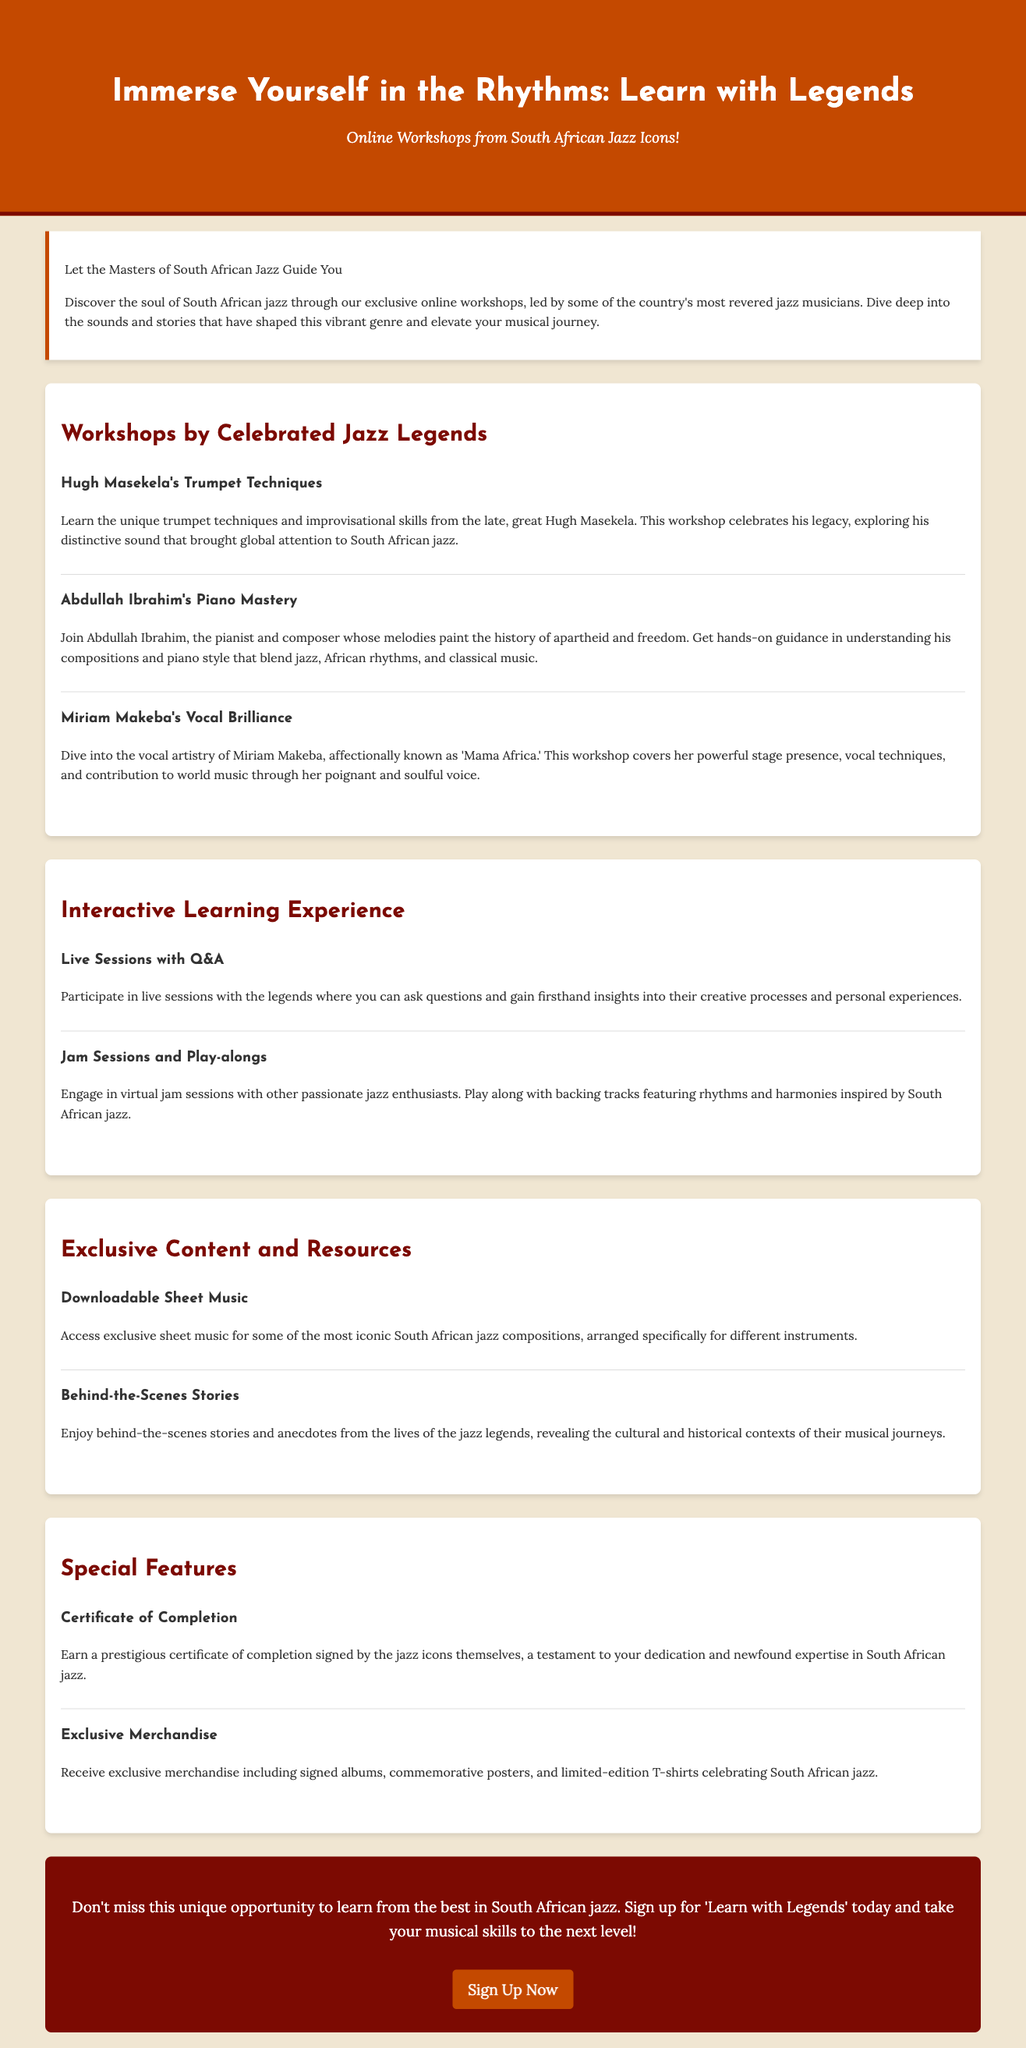What is the title of the advertisement? The title of the advertisement is prominently displayed at the top of the document.
Answer: Learn with Legends: South African Jazz Workshops Who is hosting the workshops? The document explicitly mentions that these workshops are led by South African jazz icons.
Answer: South African Jazz Icons What is one topic covered in Hugh Masekela's workshop? The document describes the focus of Hugh Masekela's workshop in detail.
Answer: Trumpet Techniques Which famous artist is known as 'Mama Africa'? The advertisement references this artist in the context of a workshop profile.
Answer: Miriam Makeba What type of certificate is offered upon completion? The document mentions this feature in the special section of the advertisement.
Answer: Certificate of Completion What kind of sessions are included in the interactive learning experience? The document provides insights into the types of interactive activities in the workshops.
Answer: Live Sessions with Q&A What can participants expect to receive as part of exclusive merchandise? The advertisement lists specific items included in the merchandise section.
Answer: Signed albums How are the workshops described in terms of participant engagement? The document emphasizes the nature of participant involvement in workshops throughout.
Answer: Interactive Learning Experience 